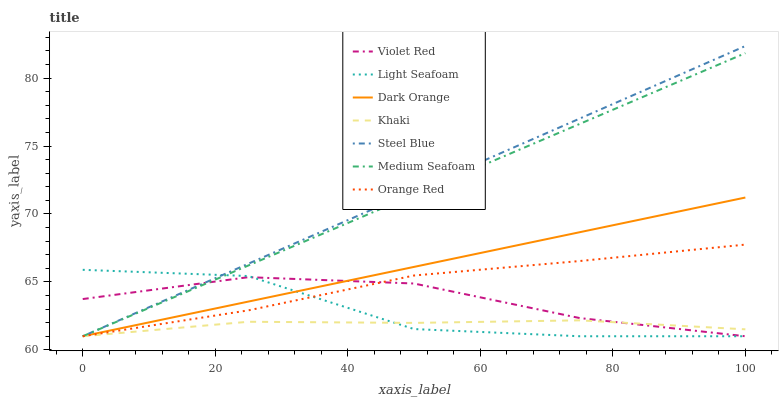Does Violet Red have the minimum area under the curve?
Answer yes or no. No. Does Violet Red have the maximum area under the curve?
Answer yes or no. No. Is Violet Red the smoothest?
Answer yes or no. No. Is Violet Red the roughest?
Answer yes or no. No. Does Violet Red have the highest value?
Answer yes or no. No. 